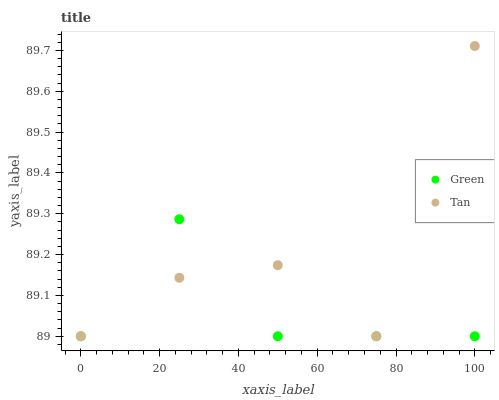Does Green have the minimum area under the curve?
Answer yes or no. Yes. Does Tan have the maximum area under the curve?
Answer yes or no. Yes. Does Green have the maximum area under the curve?
Answer yes or no. No. Is Green the smoothest?
Answer yes or no. Yes. Is Tan the roughest?
Answer yes or no. Yes. Is Green the roughest?
Answer yes or no. No. Does Tan have the lowest value?
Answer yes or no. Yes. Does Tan have the highest value?
Answer yes or no. Yes. Does Green have the highest value?
Answer yes or no. No. Does Green intersect Tan?
Answer yes or no. Yes. Is Green less than Tan?
Answer yes or no. No. Is Green greater than Tan?
Answer yes or no. No. 